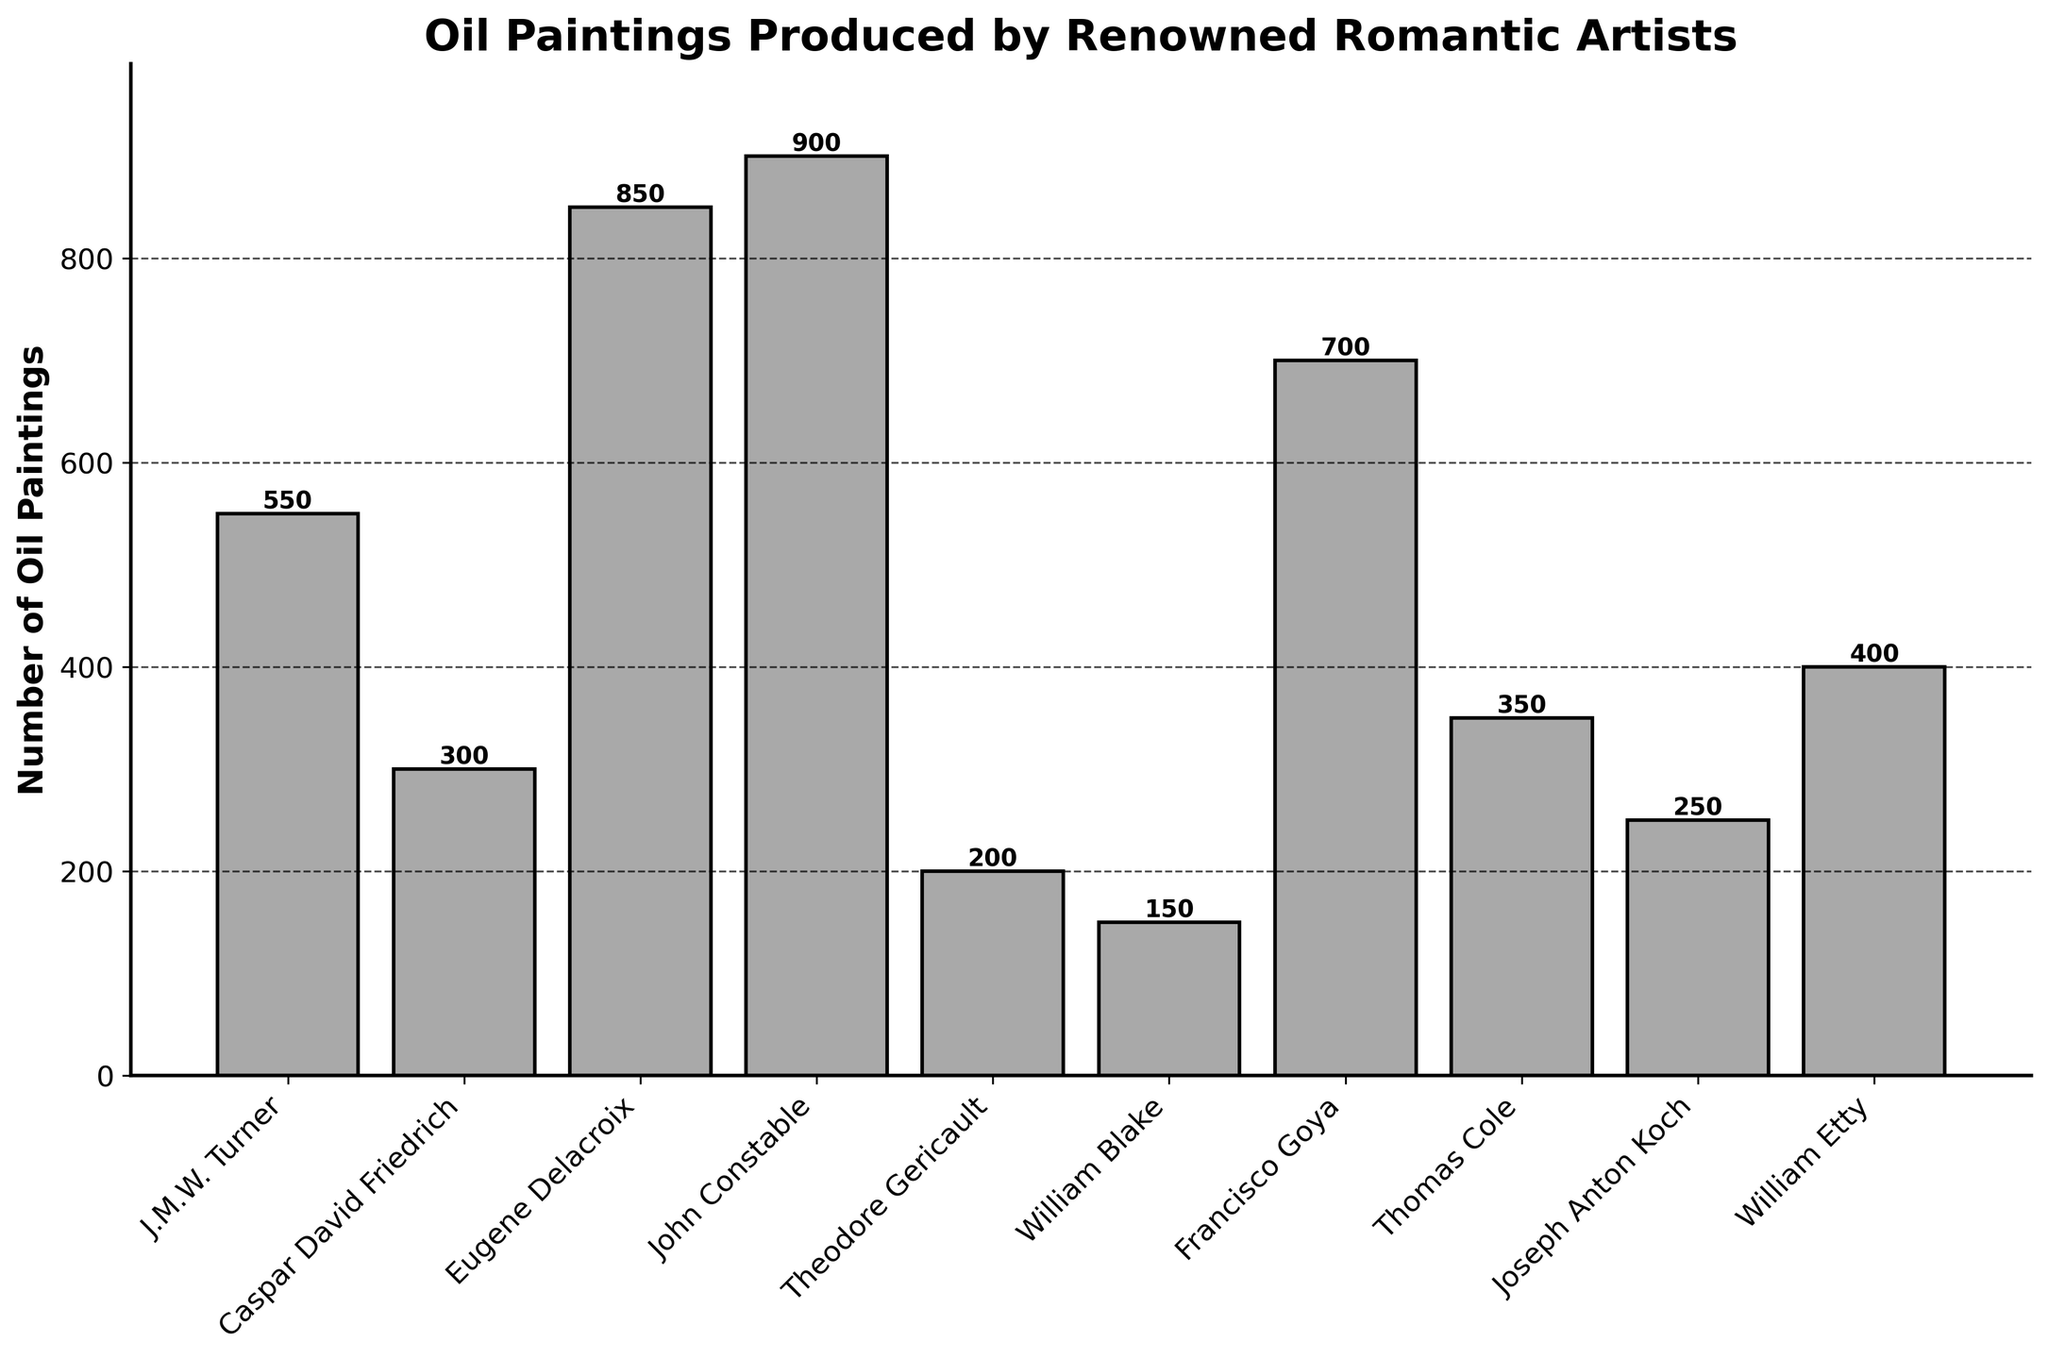What is the total number of oil paintings produced by Caspar David Friedrich and Thomas Cole? To find the total number of oil paintings by Caspar David Friedrich and Thomas Cole, we need to add their individual numbers: 300 (Friedrich) + 350 (Cole) = 650
Answer: 650 Which artist produced the highest number of oil paintings? From the bar chart, identify the artist with the highest bar. John Constable produced the highest number of oil paintings with a total of 900.
Answer: John Constable How many more oil paintings did Eugene Delacroix produce compared to William Etty? Find the number of oil paintings by Eugene Delacroix and William Etty, then subtract Etty's total from Delacroix's: 850 - 400 = 450
Answer: 450 What is the average number of oil paintings produced by all the artists? Add the total number of oil paintings for all artists and divide by the number of artists. The sum is 550 + 300 + 850 + 900 + 200 + 150 + 700 + 350 + 250 + 400 = 4650. Divide by 10 artists: 4650 / 10 = 465
Answer: 465 Is the number of oil paintings produced by Francisco Goya greater than the combined total of Theodore Gericault and William Blake? First calculate the combined totals: Gericault (200) + Blake (150) = 350. Compare it with Goya's total (700). Since 700 is greater than 350, the answer is yes.
Answer: Yes What is the difference between the number of oil paintings produced by Thomas Cole and Joseph Anton Koch? Subtract the number of oil paintings by Joseph Anton Koch from Thomas Cole: 350 - 250 = 100
Answer: 100 Rank the artists by the number of oil paintings produced from highest to lowest. List the artists in descending order based on their number of oil paintings: John Constable (900), Eugene Delacroix (850), Francisco Goya (700), J.M.W. Turner (550), William Etty (400), Thomas Cole (350), Caspar David Friedrich (300), Joseph Anton Koch (250), Theodore Gericault (200), William Blake (150).
Answer: John Constable, Eugene Delacroix, Francisco Goya, J.M.W. Turner, William Etty, Thomas Cole, Caspar David Friedrich, Joseph Anton Koch, Theodore Gericault, William Blake Which two artists produced a combined total closest to 1000 oil paintings? Add the number of oil paintings for every possible pair of artists and find which pair's total is closest to 1000. Delacroix and Goya: 850 + 700 = 1550, Turner and Delacroix: 550 + 850 = 1400, Constable and Delacroix: 900 + 850 = 1750, etc. The closest pair is Francisco Goya (700) and William Etty (400) with 700 + 400 = 1100.
Answer: Goya and Etty What is the median number of oil paintings produced by the artists? Arrange the numbers in ascending order: 150, 200, 250, 300, 350, 400, 550, 700, 850, 900. The median is the average of the 5th and 6th numbers: (350 + 400) / 2 = 375
Answer: 375 